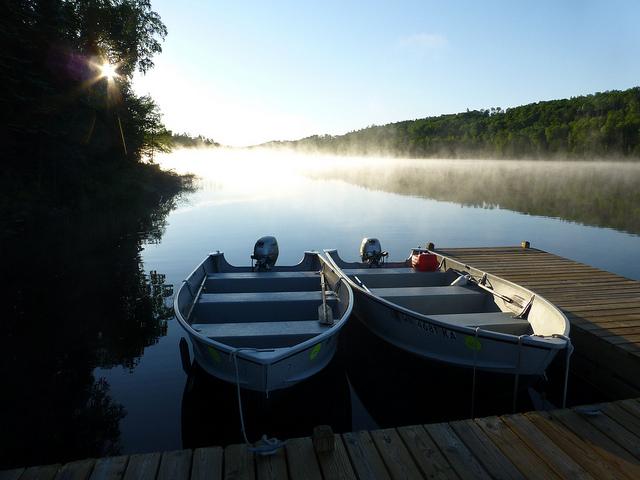Is the lake calm?
Keep it brief. Yes. How many boats are in the picture?
Concise answer only. 2. How many boats are at the dock?
Answer briefly. 2. Which boat has something red in the back?
Keep it brief. Right one. 